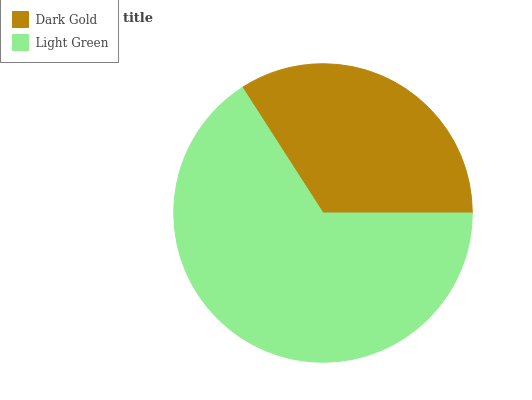Is Dark Gold the minimum?
Answer yes or no. Yes. Is Light Green the maximum?
Answer yes or no. Yes. Is Light Green the minimum?
Answer yes or no. No. Is Light Green greater than Dark Gold?
Answer yes or no. Yes. Is Dark Gold less than Light Green?
Answer yes or no. Yes. Is Dark Gold greater than Light Green?
Answer yes or no. No. Is Light Green less than Dark Gold?
Answer yes or no. No. Is Light Green the high median?
Answer yes or no. Yes. Is Dark Gold the low median?
Answer yes or no. Yes. Is Dark Gold the high median?
Answer yes or no. No. Is Light Green the low median?
Answer yes or no. No. 